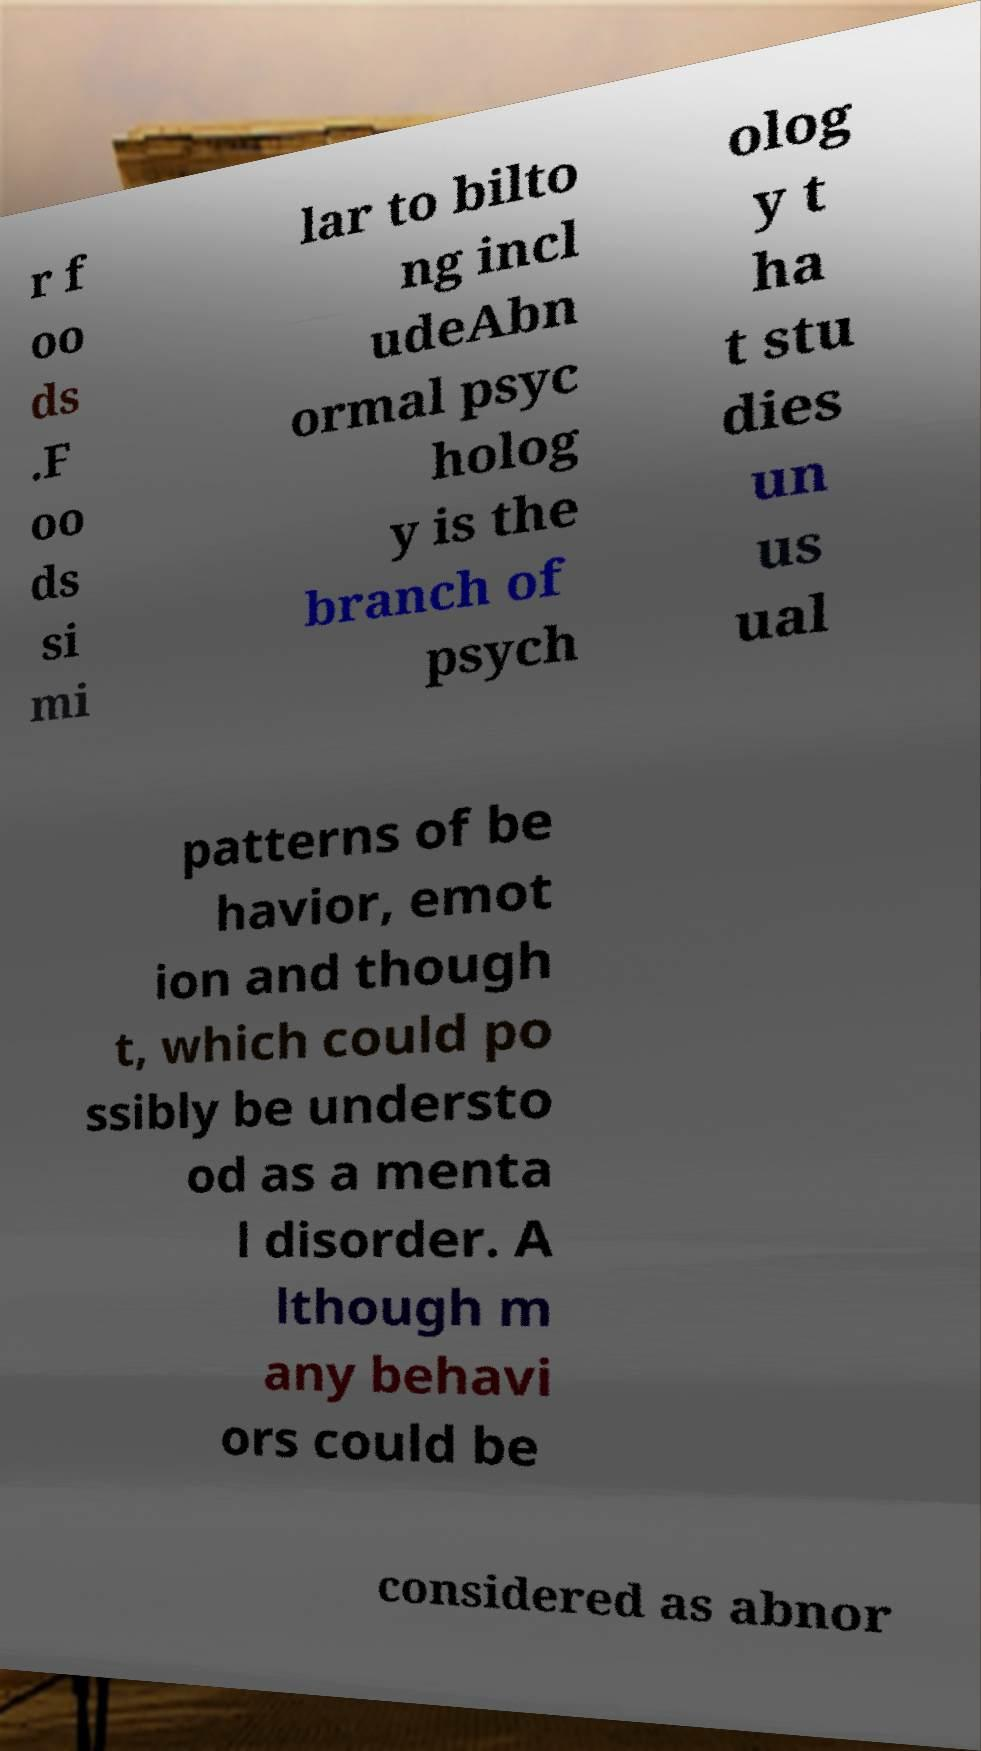Could you extract and type out the text from this image? r f oo ds .F oo ds si mi lar to bilto ng incl udeAbn ormal psyc holog y is the branch of psych olog y t ha t stu dies un us ual patterns of be havior, emot ion and though t, which could po ssibly be understo od as a menta l disorder. A lthough m any behavi ors could be considered as abnor 